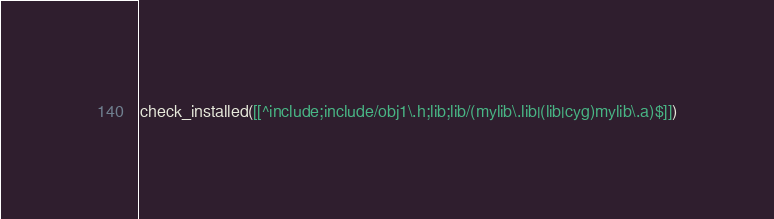<code> <loc_0><loc_0><loc_500><loc_500><_CMake_>check_installed([[^include;include/obj1\.h;lib;lib/(mylib\.lib|(lib|cyg)mylib\.a)$]])
</code> 